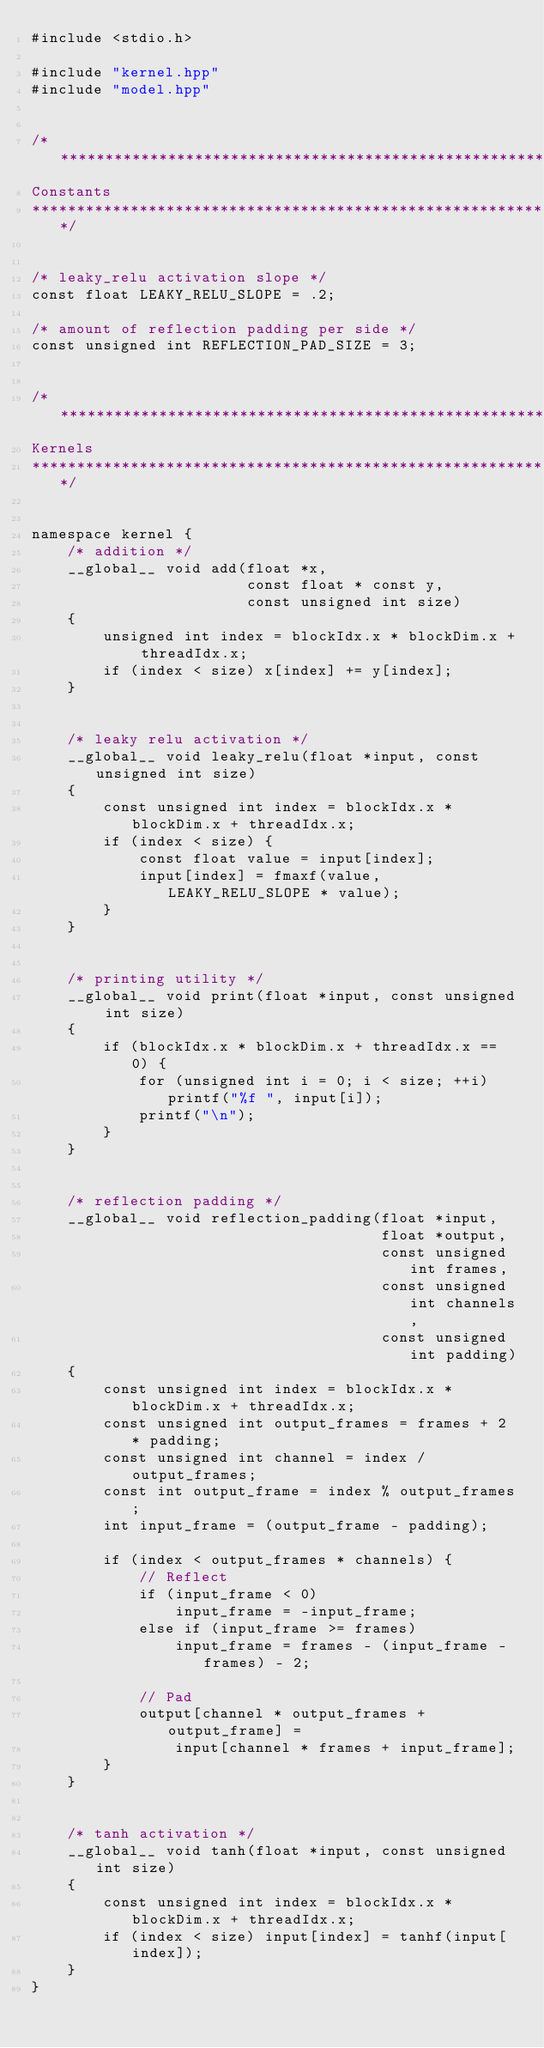Convert code to text. <code><loc_0><loc_0><loc_500><loc_500><_Cuda_>#include <stdio.h>

#include "kernel.hpp"
#include "model.hpp"


/******************************************************************************
Constants
******************************************************************************/


/* leaky_relu activation slope */
const float LEAKY_RELU_SLOPE = .2;

/* amount of reflection padding per side */
const unsigned int REFLECTION_PAD_SIZE = 3;


/******************************************************************************
Kernels
******************************************************************************/


namespace kernel {
    /* addition */
    __global__ void add(float *x,
                        const float * const y,
                        const unsigned int size)
    {
        unsigned int index = blockIdx.x * blockDim.x + threadIdx.x;
        if (index < size) x[index] += y[index];
    }


    /* leaky relu activation */
    __global__ void leaky_relu(float *input, const unsigned int size)
    {
        const unsigned int index = blockIdx.x * blockDim.x + threadIdx.x;
        if (index < size) {
            const float value = input[index];
            input[index] = fmaxf(value, LEAKY_RELU_SLOPE * value);
        }
    }


    /* printing utility */
    __global__ void print(float *input, const unsigned int size)
    {
        if (blockIdx.x * blockDim.x + threadIdx.x == 0) {
            for (unsigned int i = 0; i < size; ++i) printf("%f ", input[i]);
            printf("\n");
        }
    }


    /* reflection padding */
    __global__ void reflection_padding(float *input,
                                       float *output,
                                       const unsigned int frames,
                                       const unsigned int channels,
                                       const unsigned int padding)
    {
        const unsigned int index = blockIdx.x * blockDim.x + threadIdx.x;
        const unsigned int output_frames = frames + 2 * padding;
        const unsigned int channel = index / output_frames;
        const int output_frame = index % output_frames;
        int input_frame = (output_frame - padding);

        if (index < output_frames * channels) {
            // Reflect
            if (input_frame < 0)
                input_frame = -input_frame;
            else if (input_frame >= frames)
                input_frame = frames - (input_frame - frames) - 2;

            // Pad
            output[channel * output_frames + output_frame] =
                input[channel * frames + input_frame];
        }
    }


    /* tanh activation */
    __global__ void tanh(float *input, const unsigned int size)
    {
        const unsigned int index = blockIdx.x * blockDim.x + threadIdx.x;
        if (index < size) input[index] = tanhf(input[index]);
    }
}
</code> 